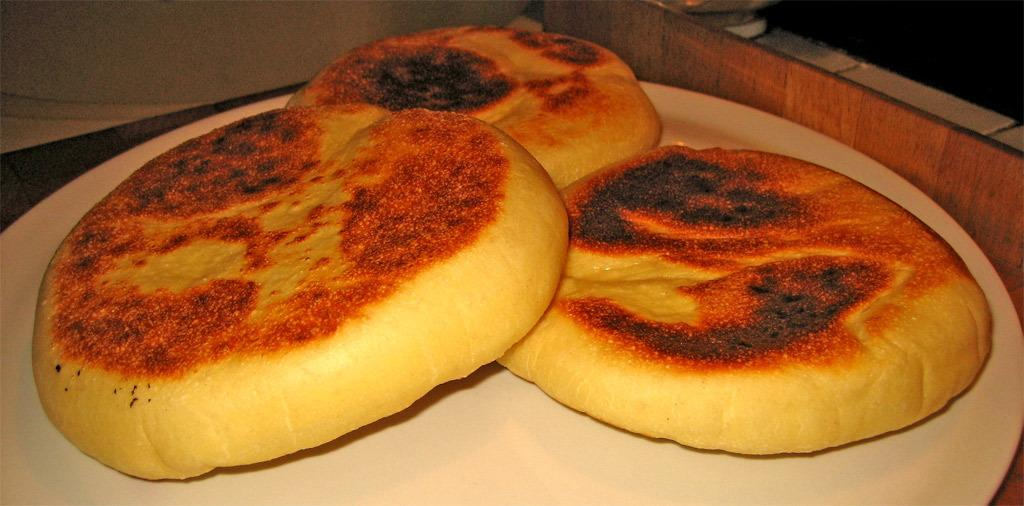What type of objects are in the image? There are round-shaped objects in the image. What are these round-shaped objects? The round-shaped objects are breeds. Where are the breeds placed? The breeds are placed on a plate. What is the plate resting on? The plate is on a table. What can be seen at the top of the image? There is a wooden object at the top of the image. What type of metal is used to create the caption in the image? There is no caption present in the image, so it is not possible to determine the type of metal used. 